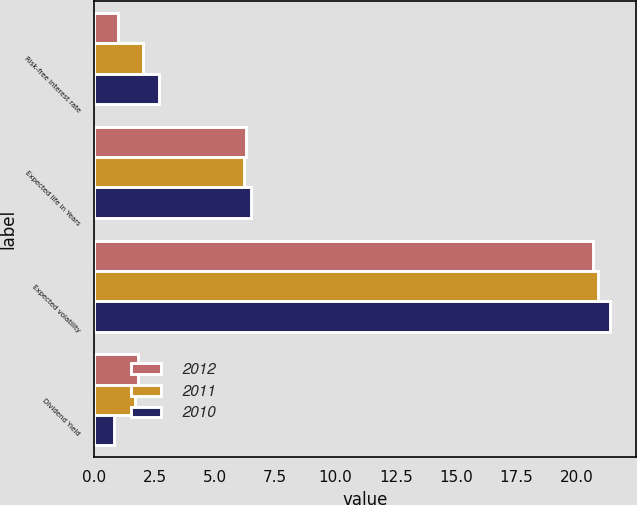Convert chart. <chart><loc_0><loc_0><loc_500><loc_500><stacked_bar_chart><ecel><fcel>Risk-free interest rate<fcel>Expected life in Years<fcel>Expected volatility<fcel>Dividend Yield<nl><fcel>2012<fcel>1<fcel>6.3<fcel>20.7<fcel>1.8<nl><fcel>2011<fcel>2<fcel>6.2<fcel>20.9<fcel>1.7<nl><fcel>2010<fcel>2.7<fcel>6.5<fcel>21.4<fcel>0.8<nl></chart> 